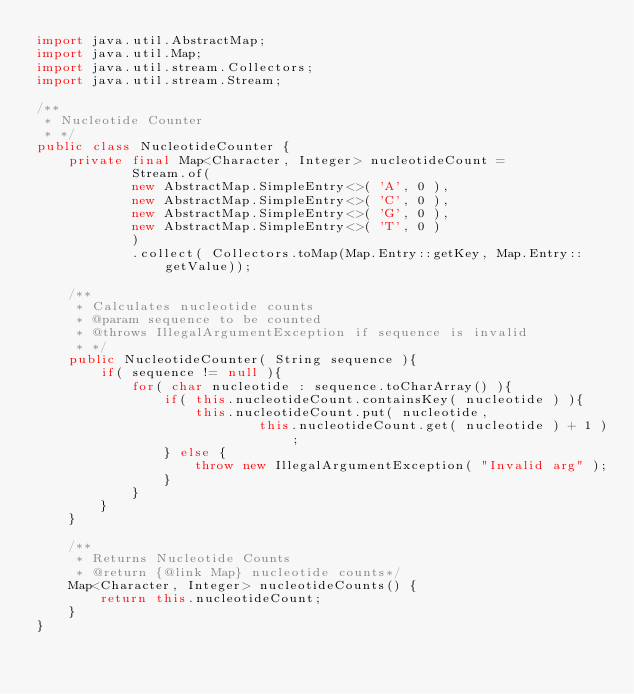<code> <loc_0><loc_0><loc_500><loc_500><_Java_>import java.util.AbstractMap;
import java.util.Map;
import java.util.stream.Collectors;
import java.util.stream.Stream;

/**
 * Nucleotide Counter
 * */
public class NucleotideCounter {
    private final Map<Character, Integer> nucleotideCount =
            Stream.of(
            new AbstractMap.SimpleEntry<>( 'A', 0 ),
            new AbstractMap.SimpleEntry<>( 'C', 0 ),
            new AbstractMap.SimpleEntry<>( 'G', 0 ),
            new AbstractMap.SimpleEntry<>( 'T', 0 )
            )
            .collect( Collectors.toMap(Map.Entry::getKey, Map.Entry::getValue));

    /**
     * Calculates nucleotide counts
     * @param sequence to be counted
     * @throws IllegalArgumentException if sequence is invalid
     * */
    public NucleotideCounter( String sequence ){
        if( sequence != null ){
            for( char nucleotide : sequence.toCharArray() ){
                if( this.nucleotideCount.containsKey( nucleotide ) ){
                    this.nucleotideCount.put( nucleotide,
                            this.nucleotideCount.get( nucleotide ) + 1 );
                } else {
                    throw new IllegalArgumentException( "Invalid arg" );
                }
            }
        }
    }

    /**
     * Returns Nucleotide Counts
     * @return {@link Map} nucleotide counts*/
    Map<Character, Integer> nucleotideCounts() {
        return this.nucleotideCount;
    }
}</code> 